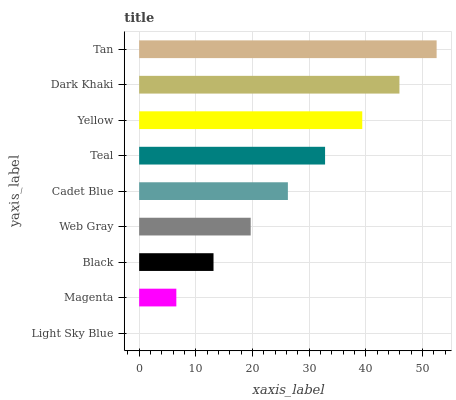Is Light Sky Blue the minimum?
Answer yes or no. Yes. Is Tan the maximum?
Answer yes or no. Yes. Is Magenta the minimum?
Answer yes or no. No. Is Magenta the maximum?
Answer yes or no. No. Is Magenta greater than Light Sky Blue?
Answer yes or no. Yes. Is Light Sky Blue less than Magenta?
Answer yes or no. Yes. Is Light Sky Blue greater than Magenta?
Answer yes or no. No. Is Magenta less than Light Sky Blue?
Answer yes or no. No. Is Cadet Blue the high median?
Answer yes or no. Yes. Is Cadet Blue the low median?
Answer yes or no. Yes. Is Web Gray the high median?
Answer yes or no. No. Is Yellow the low median?
Answer yes or no. No. 